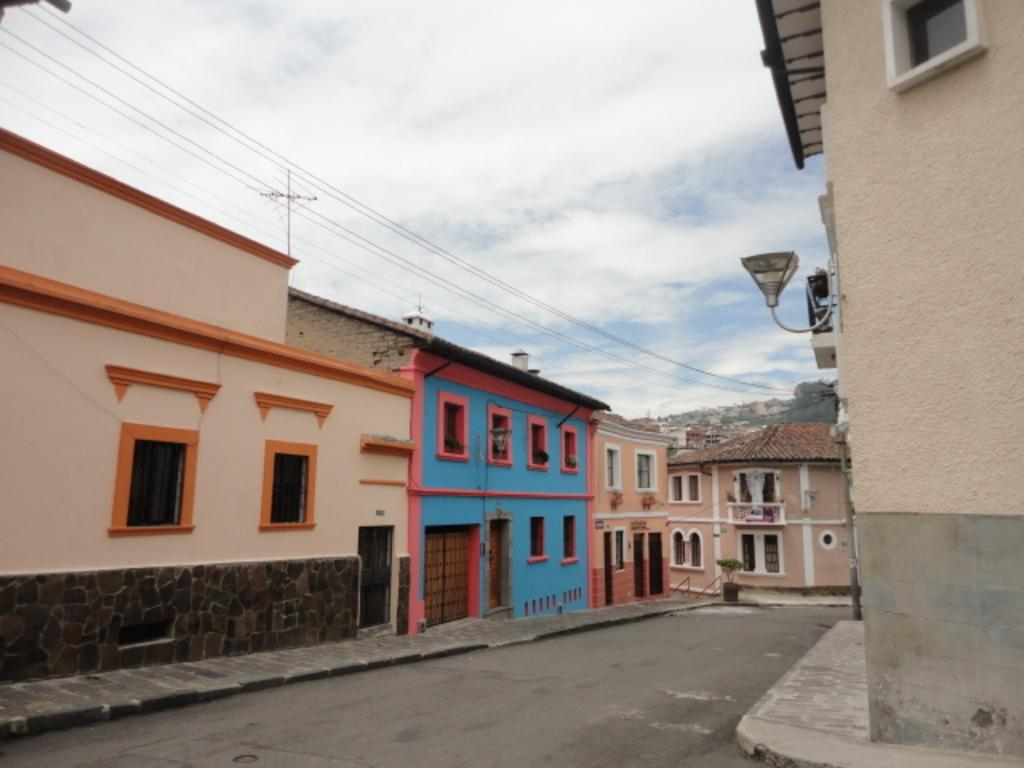What type of location is depicted in the image? There is a street in the image. What structures can be seen along the street? There are buildings in the image. What else is present in the image besides the street and buildings? There are wires in the image. What can be seen in the background of the image? There are trees and a clear sky in the background of the image. What type of celery is being used to write a letter to the grandfather in the image? There is no celery, letter, or grandfather present in the image. 